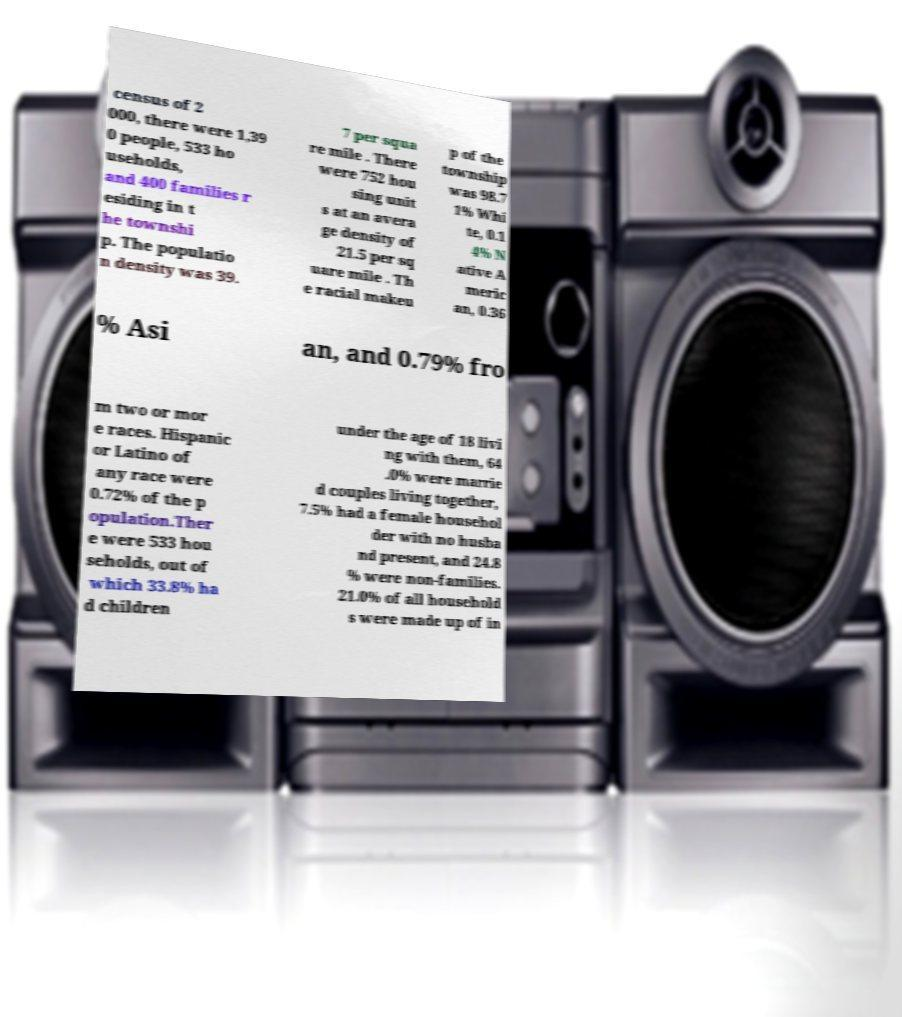For documentation purposes, I need the text within this image transcribed. Could you provide that? census of 2 000, there were 1,39 0 people, 533 ho useholds, and 400 families r esiding in t he townshi p. The populatio n density was 39. 7 per squa re mile . There were 752 hou sing unit s at an avera ge density of 21.5 per sq uare mile . Th e racial makeu p of the township was 98.7 1% Whi te, 0.1 4% N ative A meric an, 0.36 % Asi an, and 0.79% fro m two or mor e races. Hispanic or Latino of any race were 0.72% of the p opulation.Ther e were 533 hou seholds, out of which 33.8% ha d children under the age of 18 livi ng with them, 64 .0% were marrie d couples living together, 7.5% had a female househol der with no husba nd present, and 24.8 % were non-families. 21.0% of all household s were made up of in 